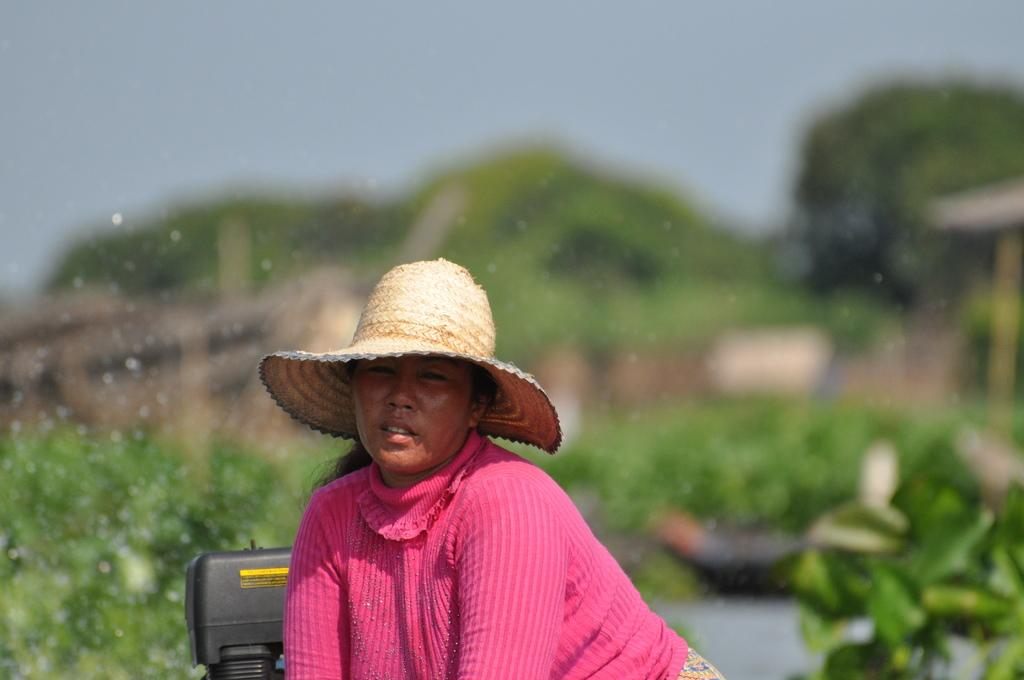Who is the main subject in the image? There is a woman in the image. What is located behind the woman? There is an object behind the woman. Can you describe the background of the image? The background of the image is blurry. What type of fuel is being used by the cows in the image? There are no cows present in the image, so it is not possible to determine what type of fuel they might be using. 